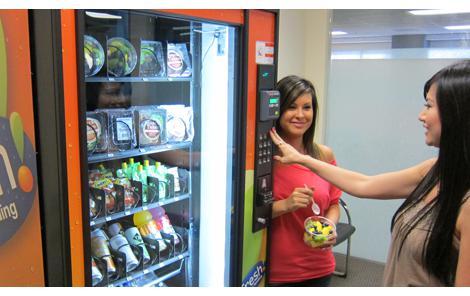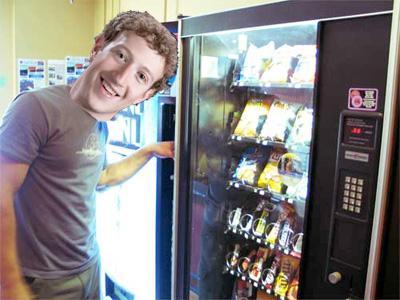The first image is the image on the left, the second image is the image on the right. Analyze the images presented: Is the assertion "In each image, at least one person is at a vending machine." valid? Answer yes or no. Yes. The first image is the image on the left, the second image is the image on the right. For the images shown, is this caption "There is a woman touching a vending machine." true? Answer yes or no. Yes. 